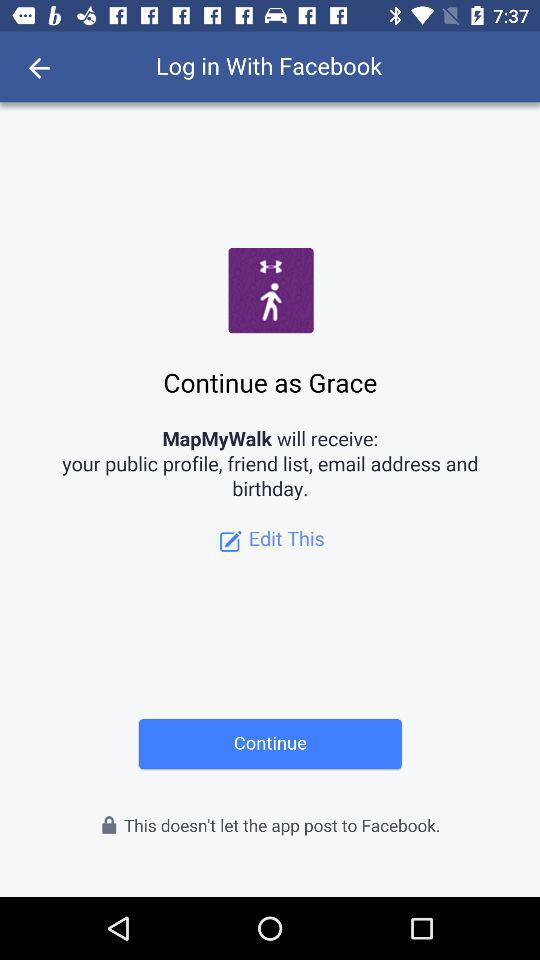What is the name of the user? The name of the user is Grace. 